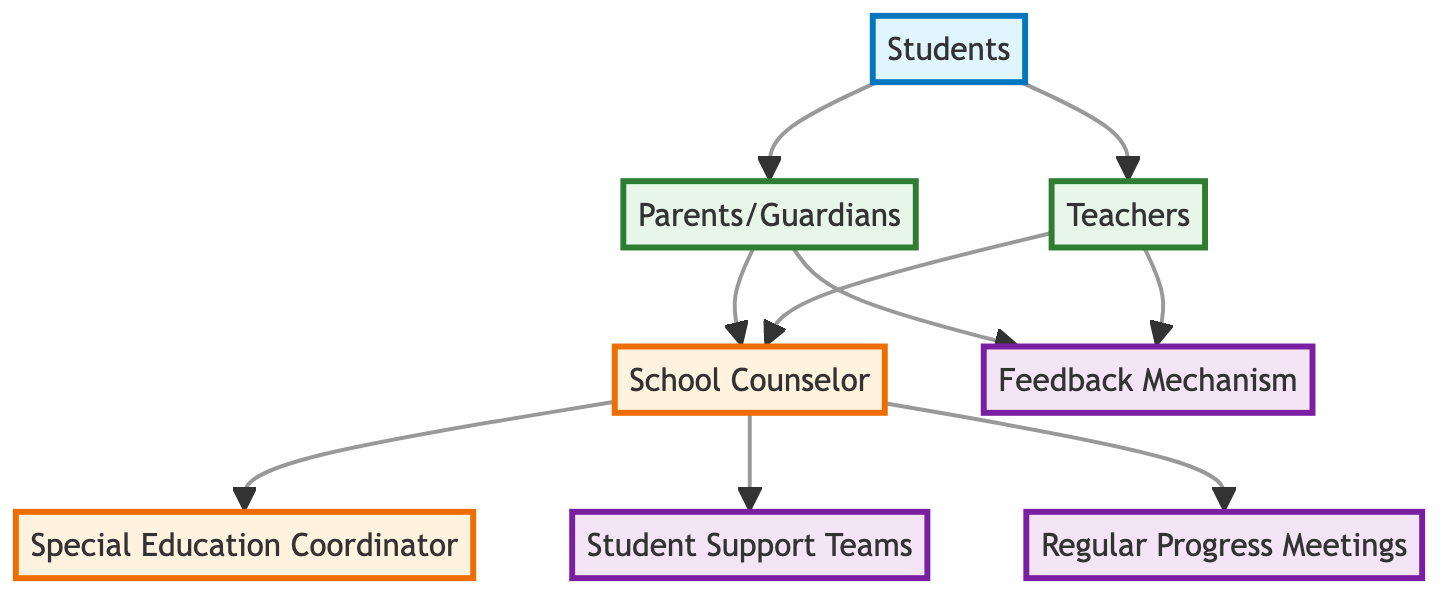What are the primary contacts for student concerns and support? The diagram indicates that Parents/Guardians are the primary contacts for student concerns and support, as they are connected directly to Students and the School Counselor.
Answer: Parents/Guardians How many nodes represent individuals involved in the student support process? By counting each unique element in the diagram, we see that there are 7 distinct nodes in total. The nodes are Students, Parents/Guardians, Teachers, School Counselor, Special Education Coordinator, Student Support Teams, and Feedback Mechanism.
Answer: 7 Which element oversees the development of special education needs? According to the diagram, the Special Education Coordinator is the element that oversees the development and implementation of special education needs as indicated by its connection to the School Counselor.
Answer: Special Education Coordinator What is the connection between Parents/Guardians and Feedback Mechanism? In the flow chart, there is a direct line connecting Parents/Guardians to the Feedback Mechanism, which indicates that parents can provide feedback on support plans.
Answer: Direct connection What steps are involved in the process of student support as represented in the diagram? The process begins with Students, who communicate with Parents/Guardians and Teachers. The next step involves Parents/Guardians and Teachers contacting the School Counselor, who then connects with the Special Education Coordinator, Student Support Teams, and oversees Regular Progress Meetings. Feedback is also facilitated directly between Parents/Guardians and Teachers.
Answer: Students to Parents/Guardians and Teachers, then to School Counselor, then to Special Education Coordinator and Student Support Teams; includes Regular Progress Meetings What role does the School Counselor play in the communication flow? The School Counselor acts as a facilitator of communication and coordination among Parents/Guardians, Teachers, Special Education Coordinator, and Student Support Teams, ensuring that all parties are informed and supported.
Answer: Facilitates communication How many connections lead from the School Counselor? The School Counselor has five distinct connections leading to other elements including the Special Education Coordinator, Student Support Teams, Regular Progress Meetings, and channels for feedback from Parents/Guardians and Teachers.
Answer: Five connections What is the purpose of the Regular Progress Meetings in this diagram? Regular Progress Meetings are scheduled discussions involving Parents, Teachers, and the School Counselor to discuss the student's progress, enabling collaboration and adjustments to the support plan as needed.
Answer: Discuss student progress What is represented by the Student Support Teams in the context of this diagram? Student Support Teams represent interdisciplinary teams that evaluate student needs and provide recommendations for support, and they are linked through the communication flow with the School Counselor.
Answer: Evaluate and recommend support 